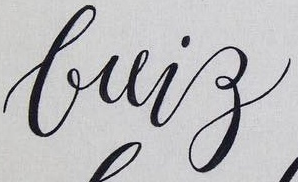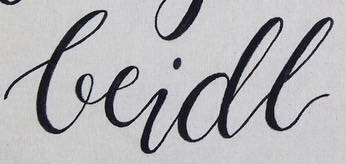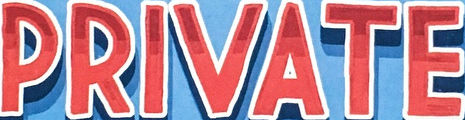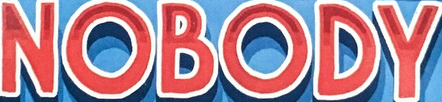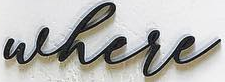What text appears in these images from left to right, separated by a semicolon? brig; beidl; PRIVATE; NOBODY; where 